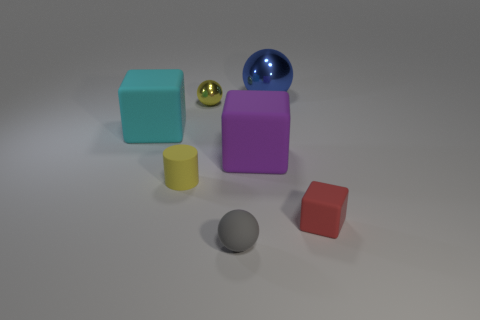This scene looks like it's set up for a reason. What do you think it might be illustrating? This image seems to be illustrating a collection of 3D geometric shapes, highlighting their different forms, sizes, and colors. It could be used as a visual aid in an educational setting to teach about geometry, volumes, and the properties of materials, given the varying textures and levels of reflectivity. 